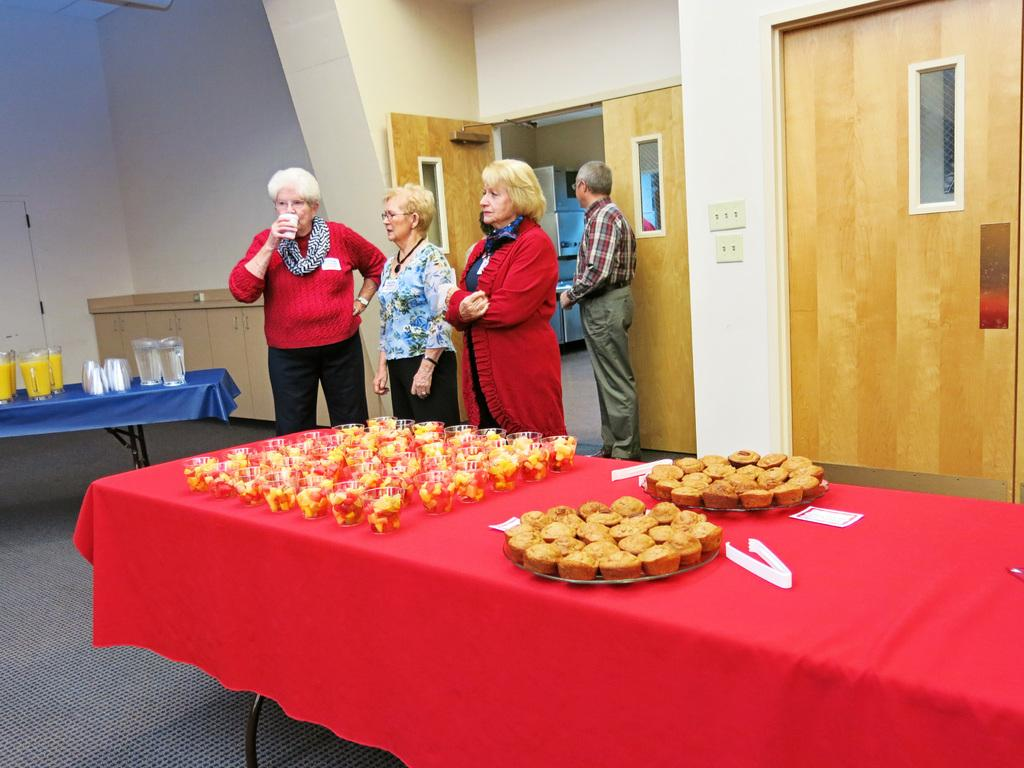How many people are in the image? There is a group of four people in the image. What are the people doing in the image? The people are standing in the image. What is in front of the people? There is a table in front of the people. What can be seen on the table? There are varieties of food on the table. Which side of the people is facing the food? The people have their left side facing the food. What else can be seen in the image? There is a door in the image. What type of tent is set up near the door in the image? There is no tent present in the image; it only features a group of people, a table, food, and a door. What kind of art is hanging on the wall behind the people? There is no mention of any art or wall in the image; it only describes a group of people, a table, food, and a door. 